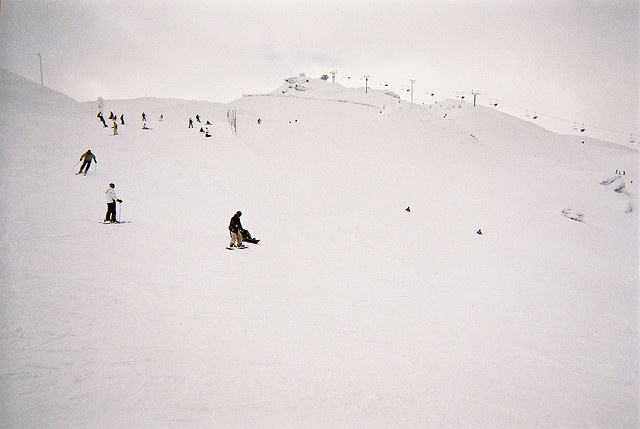Describe the objects in this image and their specific colors. I can see people in gray, black, lightgray, darkgray, and beige tones, people in gray, black, white, and tan tones, people in gray, lightgray, black, darkgray, and tan tones, people in gray, black, maroon, khaki, and olive tones, and snowboard in gray, lightgray, black, and darkgray tones in this image. 